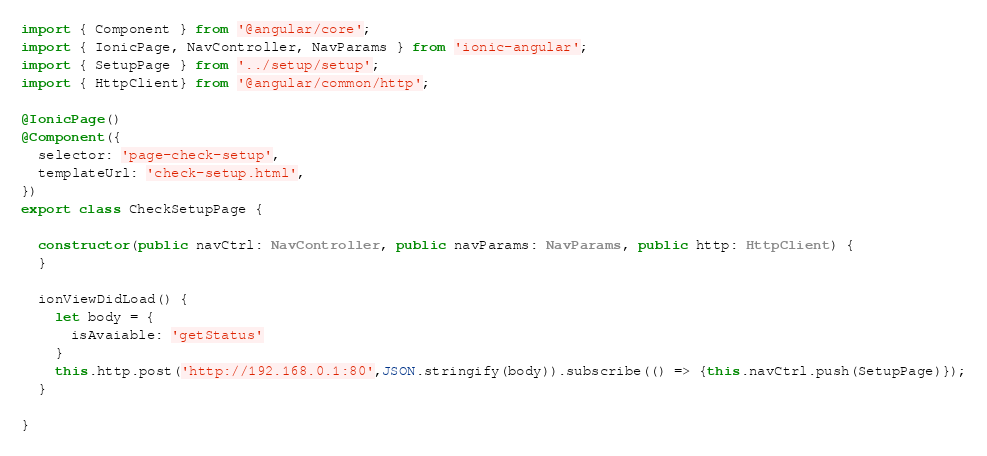Convert code to text. <code><loc_0><loc_0><loc_500><loc_500><_TypeScript_>import { Component } from '@angular/core';
import { IonicPage, NavController, NavParams } from 'ionic-angular';
import { SetupPage } from '../setup/setup';
import { HttpClient} from '@angular/common/http';

@IonicPage()
@Component({
  selector: 'page-check-setup',
  templateUrl: 'check-setup.html',
})
export class CheckSetupPage {

  constructor(public navCtrl: NavController, public navParams: NavParams, public http: HttpClient) {
  }

  ionViewDidLoad() {  
    let body = {
      isAvaiable: 'getStatus'
    }
    this.http.post('http://192.168.0.1:80',JSON.stringify(body)).subscribe(() => {this.navCtrl.push(SetupPage)});
  }

}
</code> 